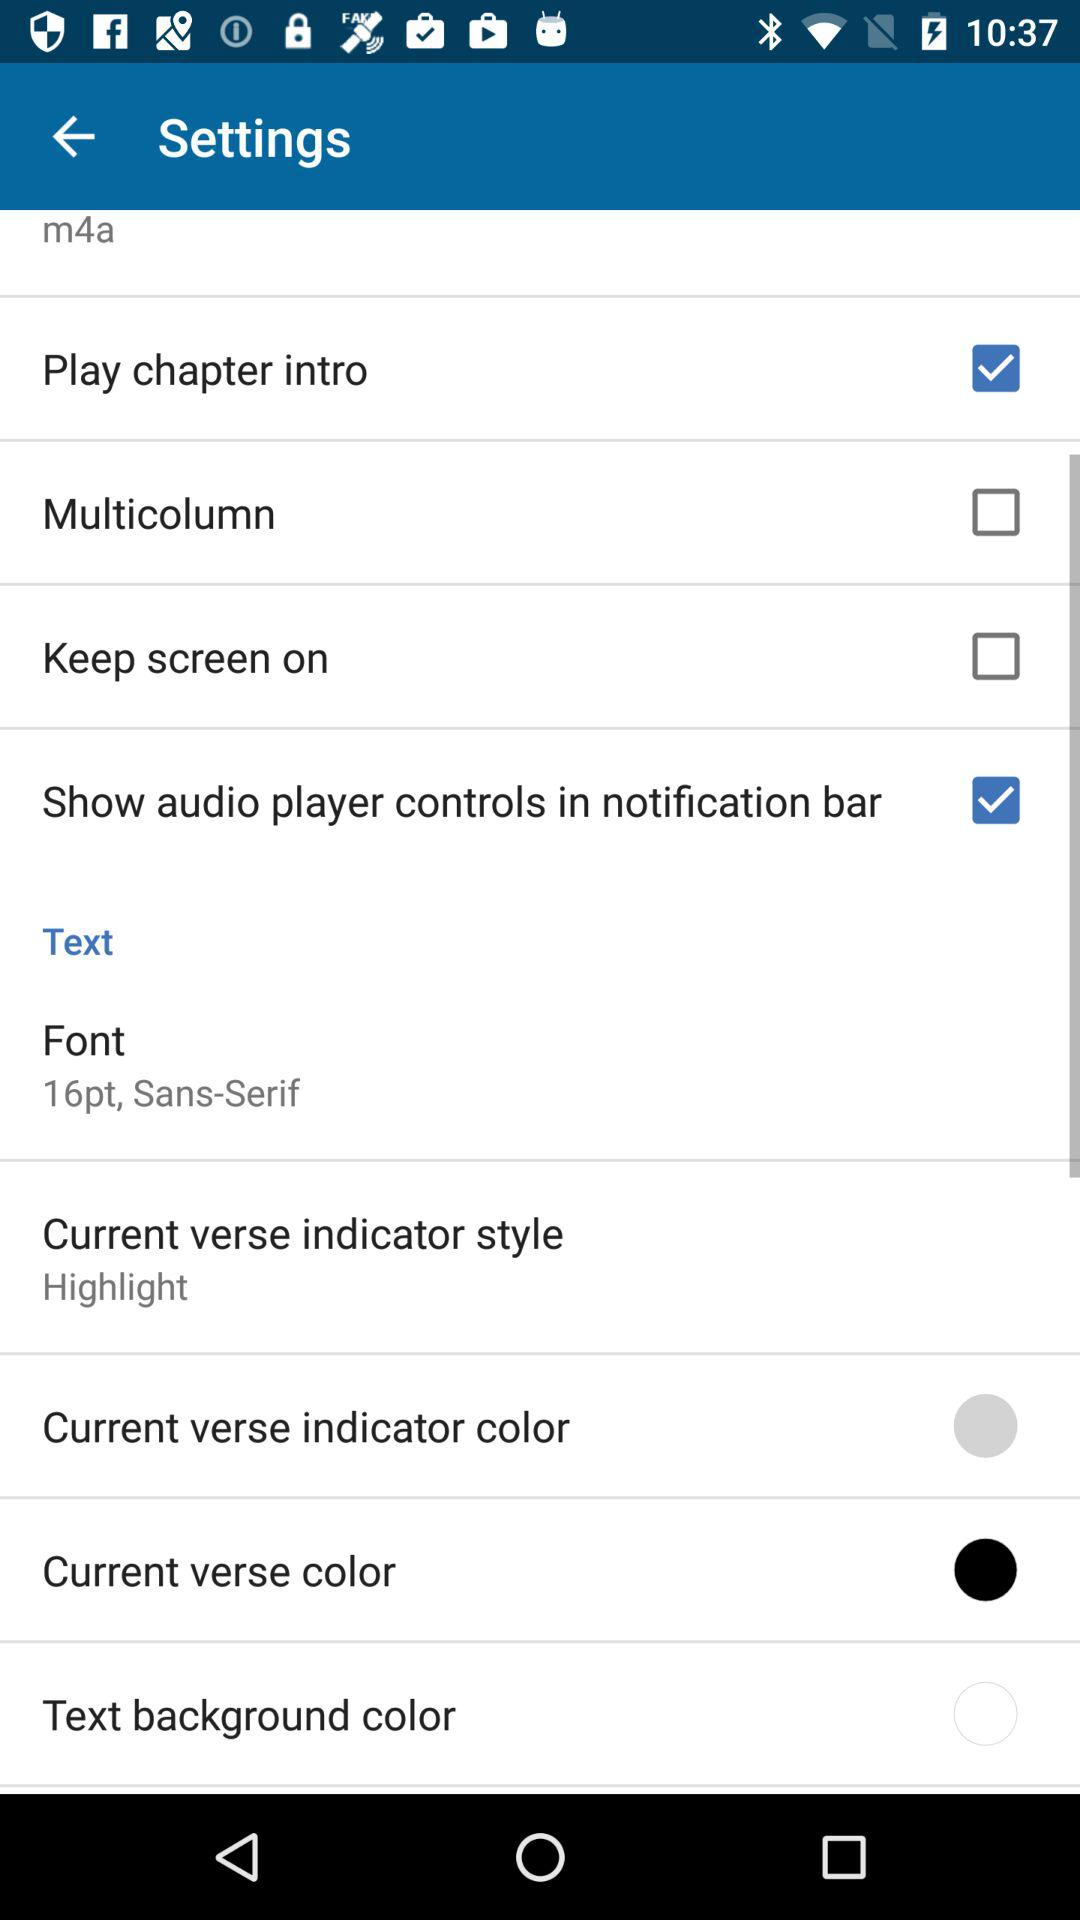What is the font type of the text? The font type of the text is "Sans-Serif". 